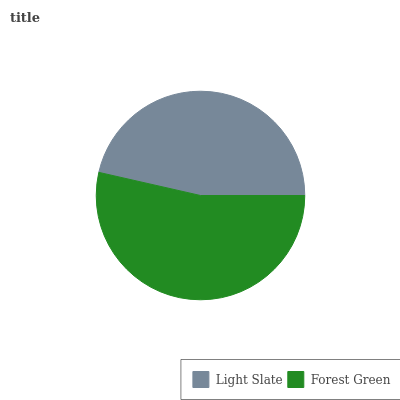Is Light Slate the minimum?
Answer yes or no. Yes. Is Forest Green the maximum?
Answer yes or no. Yes. Is Forest Green the minimum?
Answer yes or no. No. Is Forest Green greater than Light Slate?
Answer yes or no. Yes. Is Light Slate less than Forest Green?
Answer yes or no. Yes. Is Light Slate greater than Forest Green?
Answer yes or no. No. Is Forest Green less than Light Slate?
Answer yes or no. No. Is Forest Green the high median?
Answer yes or no. Yes. Is Light Slate the low median?
Answer yes or no. Yes. Is Light Slate the high median?
Answer yes or no. No. Is Forest Green the low median?
Answer yes or no. No. 